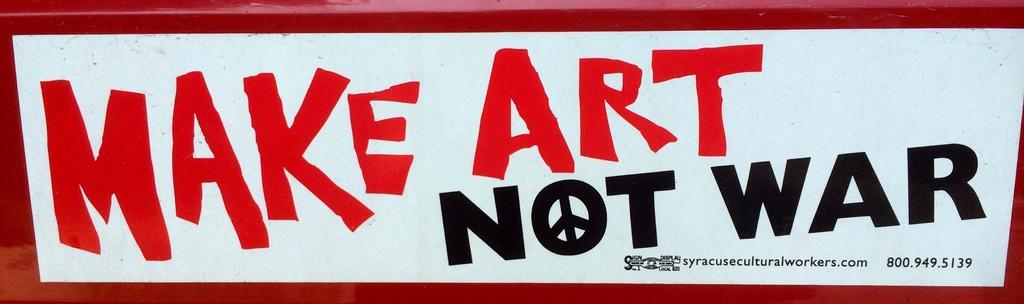What is the website mentioned on the poster?
Your response must be concise. Syracuseculturalworkers.com. What should you do instead of making war>?
Offer a terse response. Make art. 